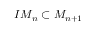<formula> <loc_0><loc_0><loc_500><loc_500>I M _ { n } \subset M _ { n + 1 }</formula> 